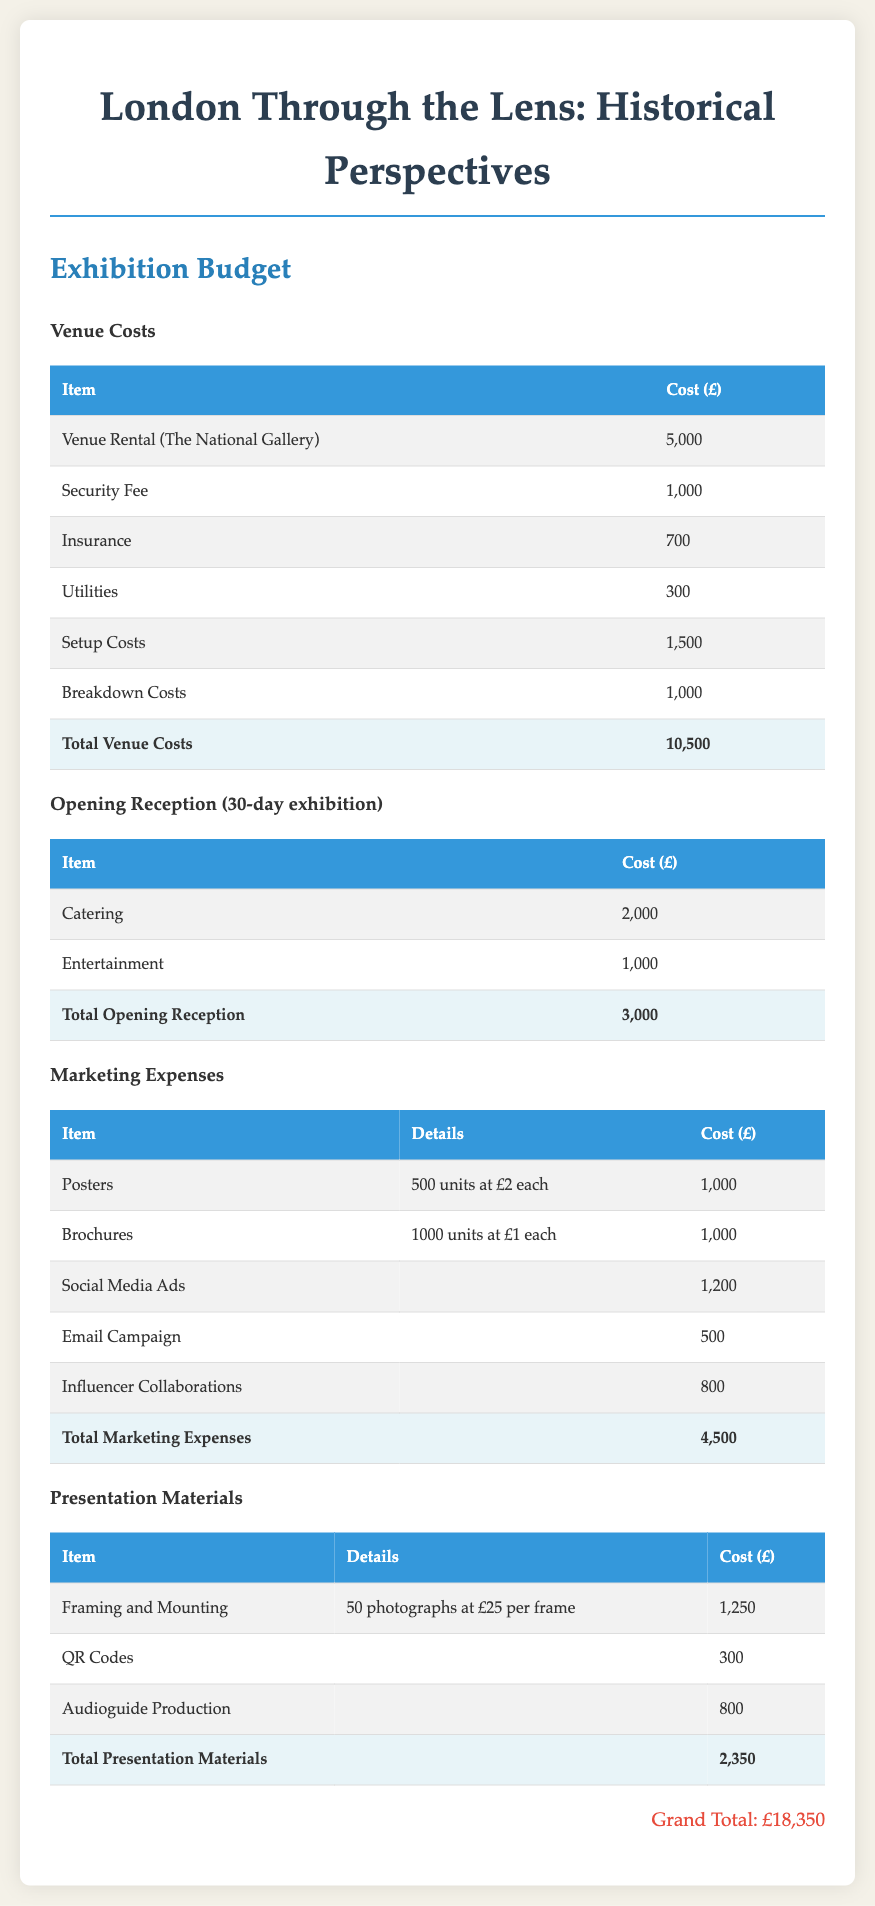What is the total venue cost? The total venue cost is displayed at the bottom of the venue costs table.
Answer: 10,500 How much is allocated for catering at the opening reception? The catering cost is listed in the opening reception section.
Answer: 2,000 What is the cost of social media ads? The cost of social media ads is included in the marketing expenses table.
Answer: 1,200 How many photographs are being framed and mounted? The number of photographs is stated in the presentation materials section.
Answer: 50 What is the grand total of the exhibition budget? The grand total is presented at the bottom of the document.
Answer: 18,350 What is the cost for insurance in the venue costs? The insurance cost is specified in the venue costs table.
Answer: 700 What is the total for presentation materials? The total for presentation materials can be found at the bottom of the presentation materials table.
Answer: 2,350 How much is spent on influencer collaborations? The influencer collaborations cost is detailed in the marketing expenses table.
Answer: 800 What is the venue for the exhibition? The venue for the exhibition is mentioned in the venue costs section.
Answer: The National Gallery 